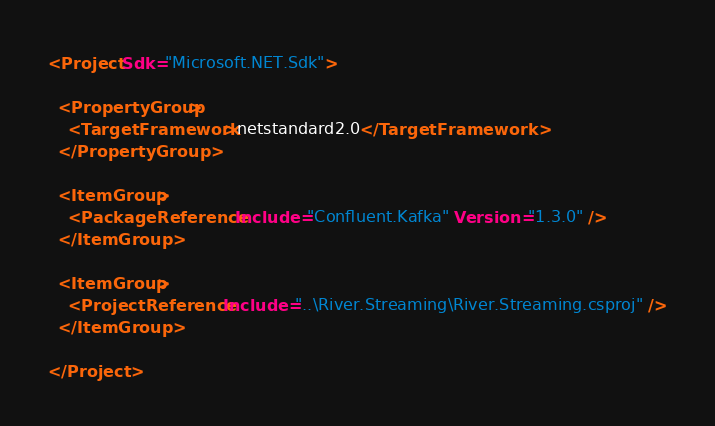<code> <loc_0><loc_0><loc_500><loc_500><_XML_><Project Sdk="Microsoft.NET.Sdk">

  <PropertyGroup>
    <TargetFramework>netstandard2.0</TargetFramework>
  </PropertyGroup>

  <ItemGroup>
    <PackageReference Include="Confluent.Kafka" Version="1.3.0" />
  </ItemGroup>

  <ItemGroup>
    <ProjectReference Include="..\River.Streaming\River.Streaming.csproj" />
  </ItemGroup>

</Project>
</code> 